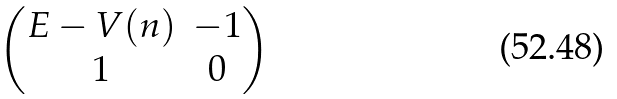Convert formula to latex. <formula><loc_0><loc_0><loc_500><loc_500>\begin{pmatrix} E - V ( n ) & - 1 \\ 1 & 0 \end{pmatrix}</formula> 